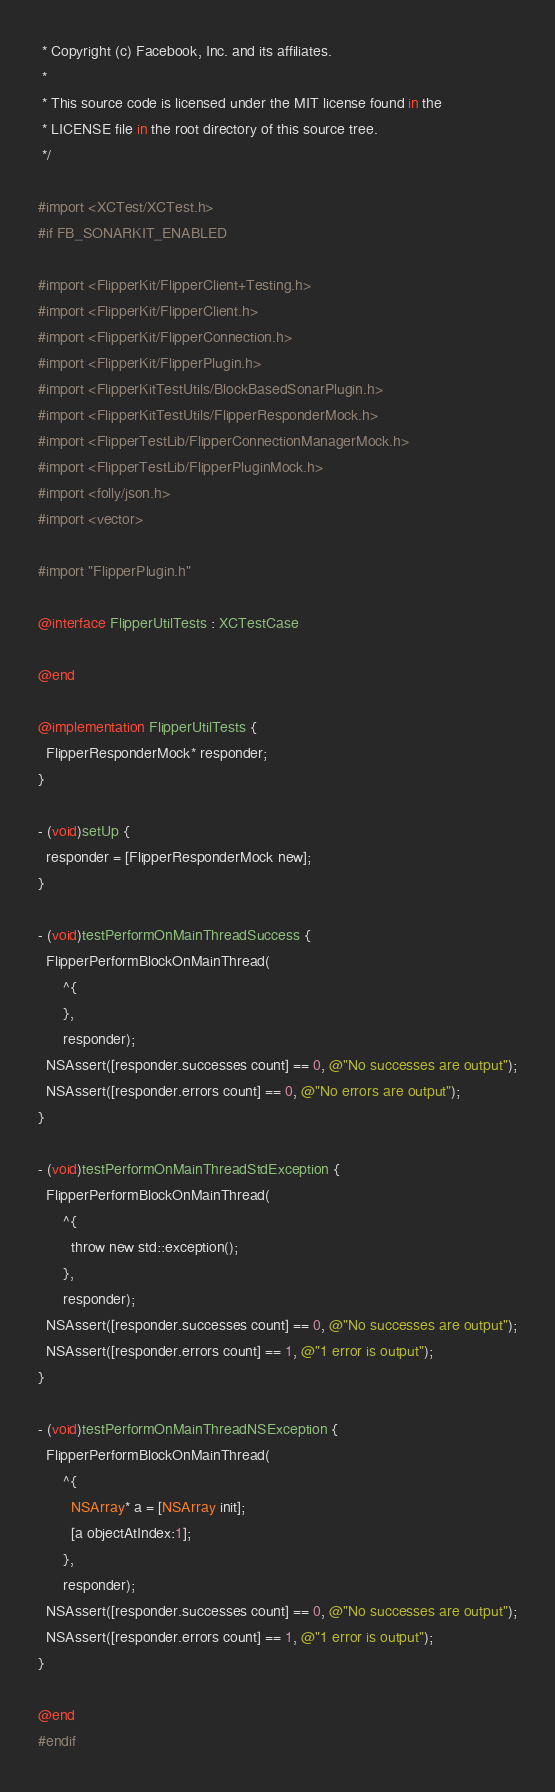Convert code to text. <code><loc_0><loc_0><loc_500><loc_500><_ObjectiveC_> * Copyright (c) Facebook, Inc. and its affiliates.
 *
 * This source code is licensed under the MIT license found in the
 * LICENSE file in the root directory of this source tree.
 */

#import <XCTest/XCTest.h>
#if FB_SONARKIT_ENABLED

#import <FlipperKit/FlipperClient+Testing.h>
#import <FlipperKit/FlipperClient.h>
#import <FlipperKit/FlipperConnection.h>
#import <FlipperKit/FlipperPlugin.h>
#import <FlipperKitTestUtils/BlockBasedSonarPlugin.h>
#import <FlipperKitTestUtils/FlipperResponderMock.h>
#import <FlipperTestLib/FlipperConnectionManagerMock.h>
#import <FlipperTestLib/FlipperPluginMock.h>
#import <folly/json.h>
#import <vector>

#import "FlipperPlugin.h"

@interface FlipperUtilTests : XCTestCase

@end

@implementation FlipperUtilTests {
  FlipperResponderMock* responder;
}

- (void)setUp {
  responder = [FlipperResponderMock new];
}

- (void)testPerformOnMainThreadSuccess {
  FlipperPerformBlockOnMainThread(
      ^{
      },
      responder);
  NSAssert([responder.successes count] == 0, @"No successes are output");
  NSAssert([responder.errors count] == 0, @"No errors are output");
}

- (void)testPerformOnMainThreadStdException {
  FlipperPerformBlockOnMainThread(
      ^{
        throw new std::exception();
      },
      responder);
  NSAssert([responder.successes count] == 0, @"No successes are output");
  NSAssert([responder.errors count] == 1, @"1 error is output");
}

- (void)testPerformOnMainThreadNSException {
  FlipperPerformBlockOnMainThread(
      ^{
        NSArray* a = [NSArray init];
        [a objectAtIndex:1];
      },
      responder);
  NSAssert([responder.successes count] == 0, @"No successes are output");
  NSAssert([responder.errors count] == 1, @"1 error is output");
}

@end
#endif
</code> 